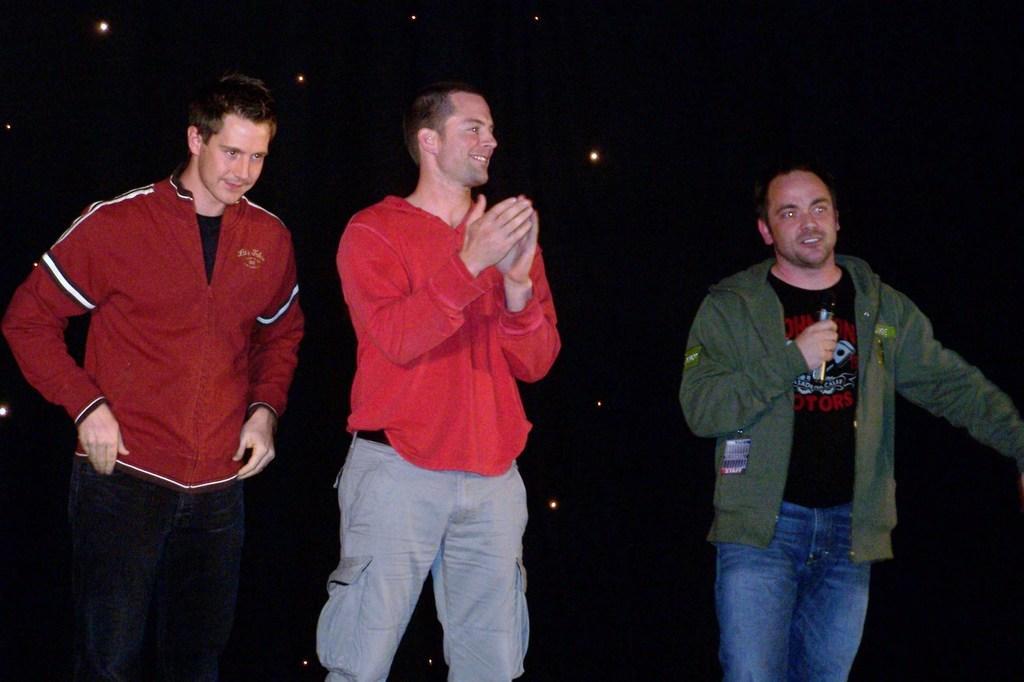Can you describe this image briefly? In this image there are three man, a man holding a mic in his hand, in the background it is dark. 